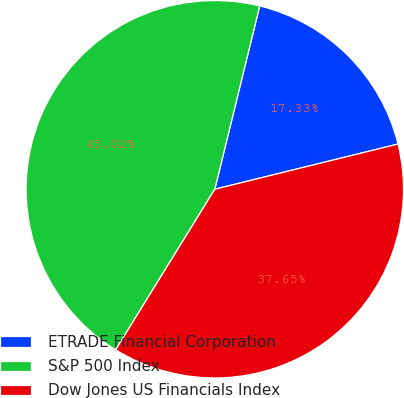<chart> <loc_0><loc_0><loc_500><loc_500><pie_chart><fcel>ETRADE Financial Corporation<fcel>S&P 500 Index<fcel>Dow Jones US Financials Index<nl><fcel>17.33%<fcel>45.02%<fcel>37.65%<nl></chart> 